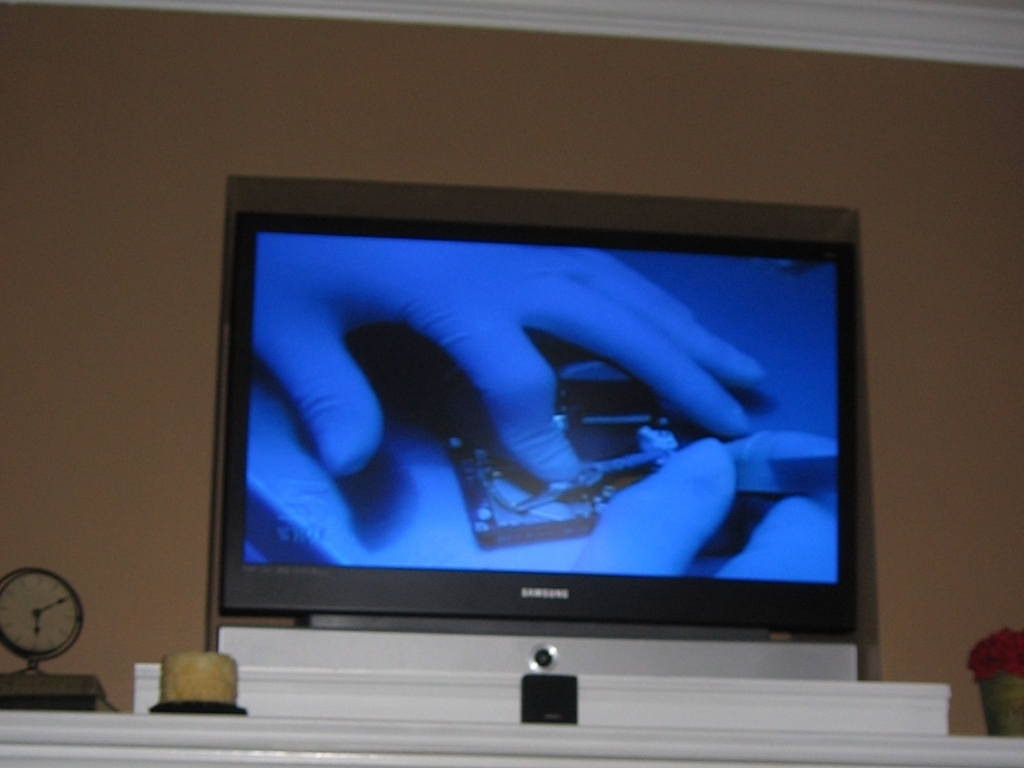What details can you provide about the room? The room has a muted color scheme with beige walls and a white mantelpiece. On the mantelpiece, there is a small clock to the left and what appears to be a candle holder or small container to the right. The television is a flat-screen Samsung model that is quite large, dominating the space on the mantel. 